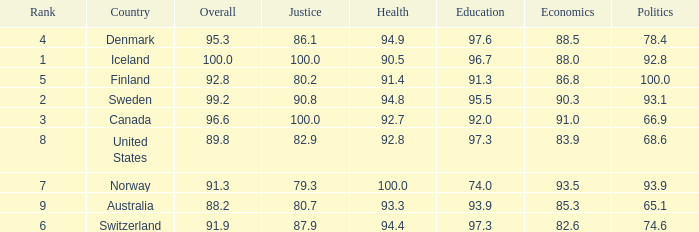What's the economics score with justice being 90.8 90.3. 